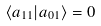<formula> <loc_0><loc_0><loc_500><loc_500>\langle a _ { 1 1 } | a _ { 0 1 } \rangle = 0</formula> 